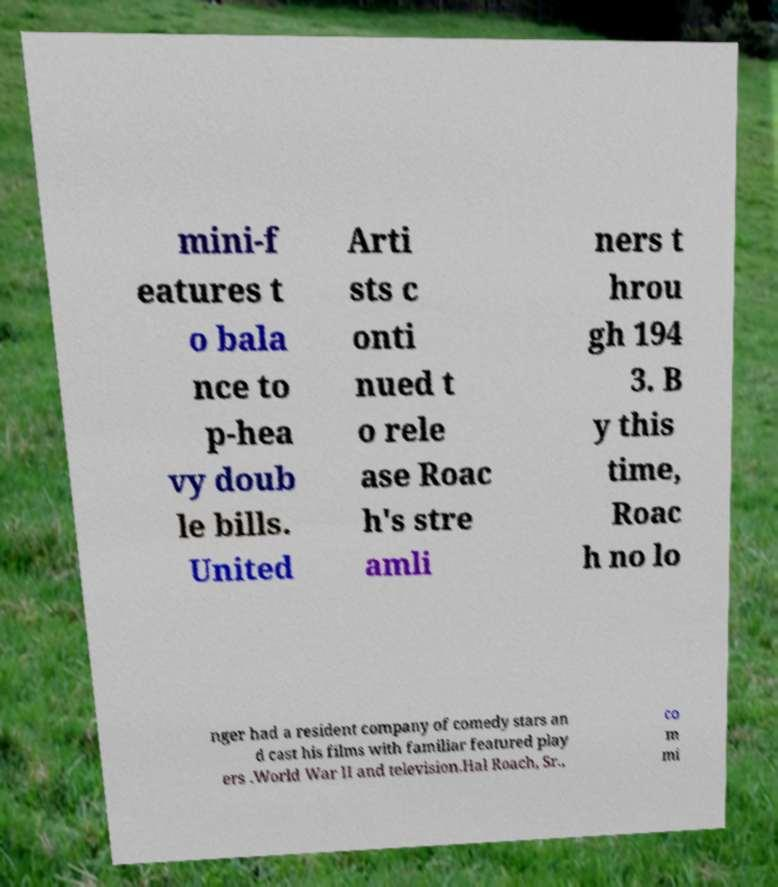Could you extract and type out the text from this image? mini-f eatures t o bala nce to p-hea vy doub le bills. United Arti sts c onti nued t o rele ase Roac h's stre amli ners t hrou gh 194 3. B y this time, Roac h no lo nger had a resident company of comedy stars an d cast his films with familiar featured play ers .World War II and television.Hal Roach, Sr., co m mi 